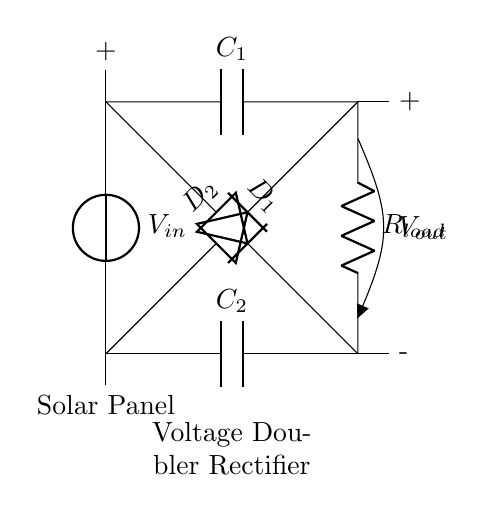What is the input voltage of this circuit? The input voltage is represented by V_in, indicated at the top left corner of the circuit.
Answer: V_in What type of diodes are used in this circuit? The circuit includes two diodes, D_1 and D_2, as labeled in the diagram.
Answer: Diodes How many capacitors are present in the circuit? There are two capacitors, C_1 and C_2, shown connected in the circuit.
Answer: Two What is the purpose of the load resistor R_load? The load resistor R_load is where the output voltage V_out is applied, allowing the circuit to deliver power to a connected device.
Answer: Deliver power How does the voltage doubler function in this circuit? The voltage doubler is achieved by the configuration of the capacitors and diodes, allowing the output voltage to be approximately double the input voltage by storing energy in the capacitors when the diodes are conducting in alternate cycles.
Answer: Doubles voltage What will happen if one of the diodes fails? If one of the diodes fails, the circuit will not function properly, likely leading to a reduced output voltage or complete failure to rectify the input voltage, as the current path will be disrupted.
Answer: Output voltage drops What is the relationship between V_out and V_in in this configuration? In a voltage doubler rectifier circuit, the output voltage V_out is roughly twice the input voltage V_in, based on the ideal behavior of the capacitors and diodes under load.
Answer: V_out ≈ 2 * V_in 